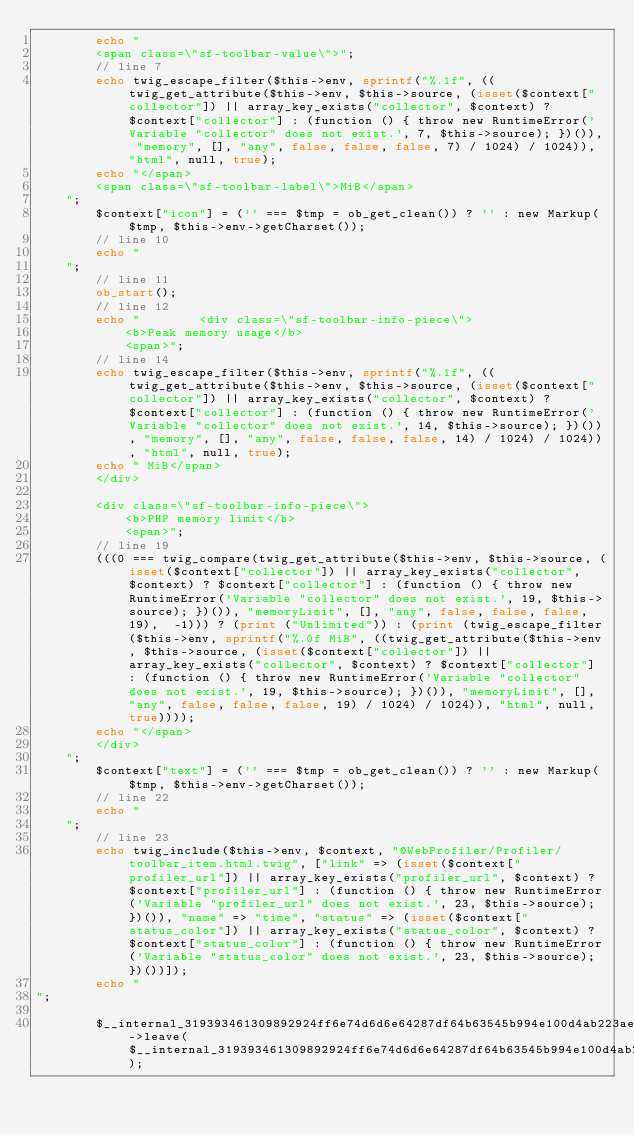<code> <loc_0><loc_0><loc_500><loc_500><_PHP_>        echo "
        <span class=\"sf-toolbar-value\">";
        // line 7
        echo twig_escape_filter($this->env, sprintf("%.1f", ((twig_get_attribute($this->env, $this->source, (isset($context["collector"]) || array_key_exists("collector", $context) ? $context["collector"] : (function () { throw new RuntimeError('Variable "collector" does not exist.', 7, $this->source); })()), "memory", [], "any", false, false, false, 7) / 1024) / 1024)), "html", null, true);
        echo "</span>
        <span class=\"sf-toolbar-label\">MiB</span>
    ";
        $context["icon"] = ('' === $tmp = ob_get_clean()) ? '' : new Markup($tmp, $this->env->getCharset());
        // line 10
        echo "
    ";
        // line 11
        ob_start();
        // line 12
        echo "        <div class=\"sf-toolbar-info-piece\">
            <b>Peak memory usage</b>
            <span>";
        // line 14
        echo twig_escape_filter($this->env, sprintf("%.1f", ((twig_get_attribute($this->env, $this->source, (isset($context["collector"]) || array_key_exists("collector", $context) ? $context["collector"] : (function () { throw new RuntimeError('Variable "collector" does not exist.', 14, $this->source); })()), "memory", [], "any", false, false, false, 14) / 1024) / 1024)), "html", null, true);
        echo " MiB</span>
        </div>

        <div class=\"sf-toolbar-info-piece\">
            <b>PHP memory limit</b>
            <span>";
        // line 19
        (((0 === twig_compare(twig_get_attribute($this->env, $this->source, (isset($context["collector"]) || array_key_exists("collector", $context) ? $context["collector"] : (function () { throw new RuntimeError('Variable "collector" does not exist.', 19, $this->source); })()), "memoryLimit", [], "any", false, false, false, 19),  -1))) ? (print ("Unlimited")) : (print (twig_escape_filter($this->env, sprintf("%.0f MiB", ((twig_get_attribute($this->env, $this->source, (isset($context["collector"]) || array_key_exists("collector", $context) ? $context["collector"] : (function () { throw new RuntimeError('Variable "collector" does not exist.', 19, $this->source); })()), "memoryLimit", [], "any", false, false, false, 19) / 1024) / 1024)), "html", null, true))));
        echo "</span>
        </div>
    ";
        $context["text"] = ('' === $tmp = ob_get_clean()) ? '' : new Markup($tmp, $this->env->getCharset());
        // line 22
        echo "
    ";
        // line 23
        echo twig_include($this->env, $context, "@WebProfiler/Profiler/toolbar_item.html.twig", ["link" => (isset($context["profiler_url"]) || array_key_exists("profiler_url", $context) ? $context["profiler_url"] : (function () { throw new RuntimeError('Variable "profiler_url" does not exist.', 23, $this->source); })()), "name" => "time", "status" => (isset($context["status_color"]) || array_key_exists("status_color", $context) ? $context["status_color"] : (function () { throw new RuntimeError('Variable "status_color" does not exist.', 23, $this->source); })())]);
        echo "
";
        
        $__internal_319393461309892924ff6e74d6d6e64287df64b63545b994e100d4ab223aed02->leave($__internal_319393461309892924ff6e74d6d6e64287df64b63545b994e100d4ab223aed02_prof);

        </code> 